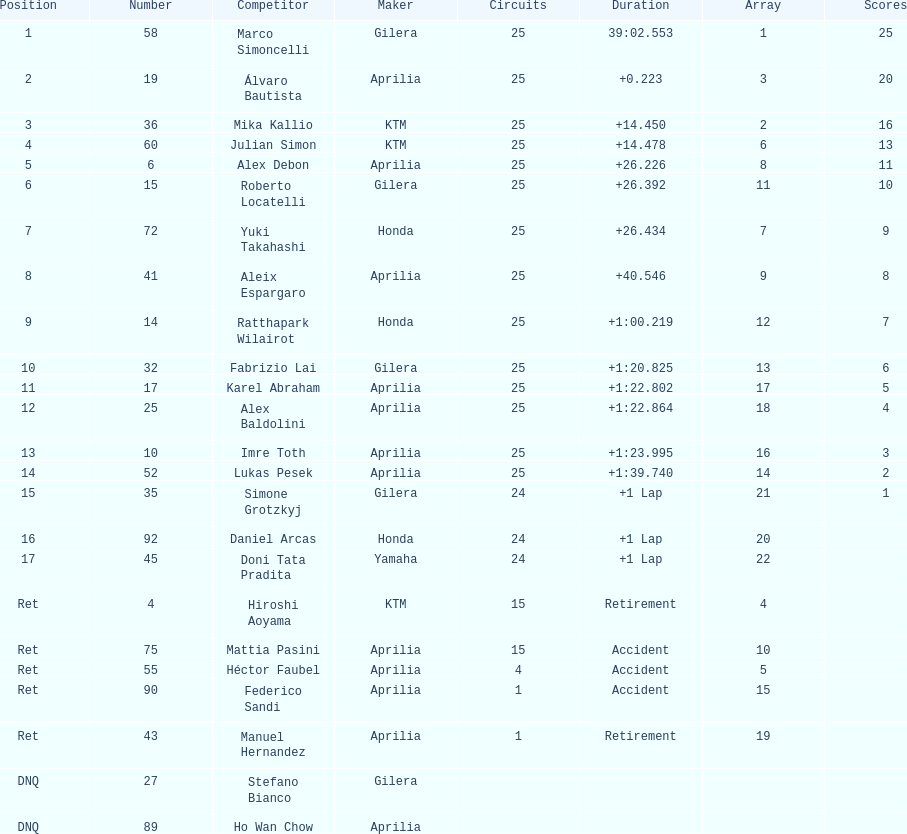Who is marco simoncelli's manufacturer Gilera. 